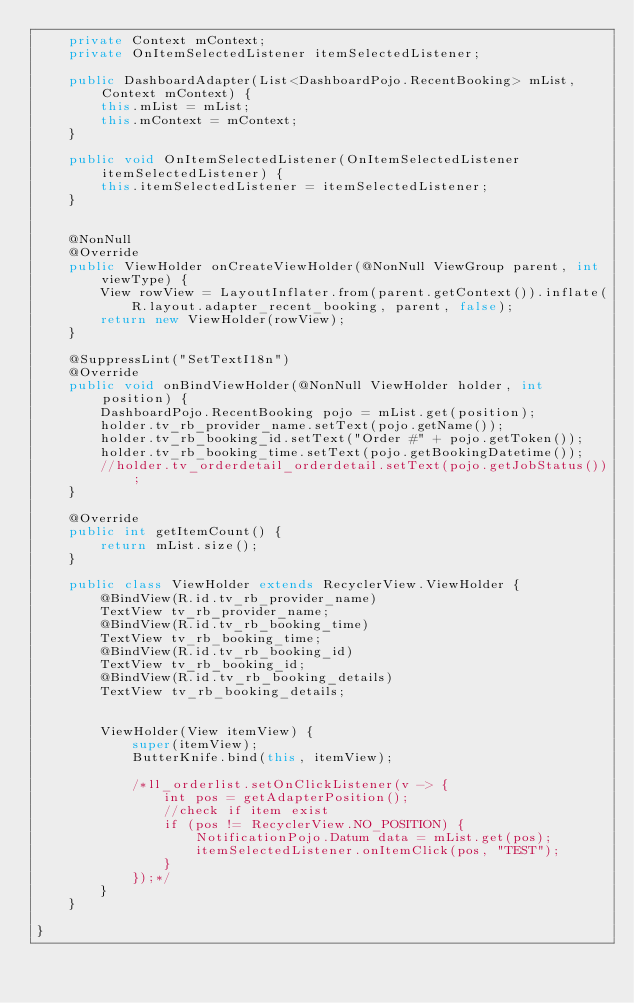<code> <loc_0><loc_0><loc_500><loc_500><_Java_>    private Context mContext;
    private OnItemSelectedListener itemSelectedListener;

    public DashboardAdapter(List<DashboardPojo.RecentBooking> mList, Context mContext) {
        this.mList = mList;
        this.mContext = mContext;
    }

    public void OnItemSelectedListener(OnItemSelectedListener itemSelectedListener) {
        this.itemSelectedListener = itemSelectedListener;
    }


    @NonNull
    @Override
    public ViewHolder onCreateViewHolder(@NonNull ViewGroup parent, int viewType) {
        View rowView = LayoutInflater.from(parent.getContext()).inflate(R.layout.adapter_recent_booking, parent, false);
        return new ViewHolder(rowView);
    }

    @SuppressLint("SetTextI18n")
    @Override
    public void onBindViewHolder(@NonNull ViewHolder holder, int position) {
        DashboardPojo.RecentBooking pojo = mList.get(position);
        holder.tv_rb_provider_name.setText(pojo.getName());
        holder.tv_rb_booking_id.setText("Order #" + pojo.getToken());
        holder.tv_rb_booking_time.setText(pojo.getBookingDatetime());
        //holder.tv_orderdetail_orderdetail.setText(pojo.getJobStatus());
    }

    @Override
    public int getItemCount() {
        return mList.size();
    }

    public class ViewHolder extends RecyclerView.ViewHolder {
        @BindView(R.id.tv_rb_provider_name)
        TextView tv_rb_provider_name;
        @BindView(R.id.tv_rb_booking_time)
        TextView tv_rb_booking_time;
        @BindView(R.id.tv_rb_booking_id)
        TextView tv_rb_booking_id;
        @BindView(R.id.tv_rb_booking_details)
        TextView tv_rb_booking_details;


        ViewHolder(View itemView) {
            super(itemView);
            ButterKnife.bind(this, itemView);

            /*ll_orderlist.setOnClickListener(v -> {
                int pos = getAdapterPosition();
                //check if item exist
                if (pos != RecyclerView.NO_POSITION) {
                    NotificationPojo.Datum data = mList.get(pos);
                    itemSelectedListener.onItemClick(pos, "TEST");
                }
            });*/
        }
    }

}

</code> 